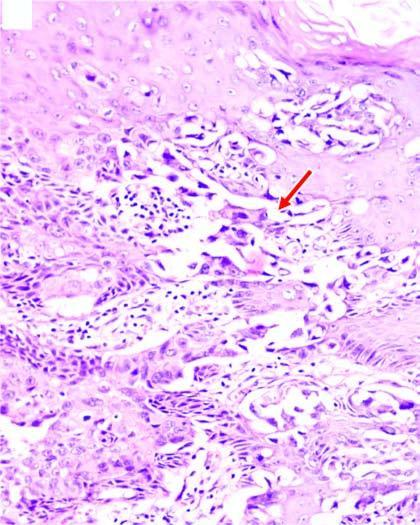re clefts in the epidermal layers containing large tumour cells?
Answer the question using a single word or phrase. Yes 